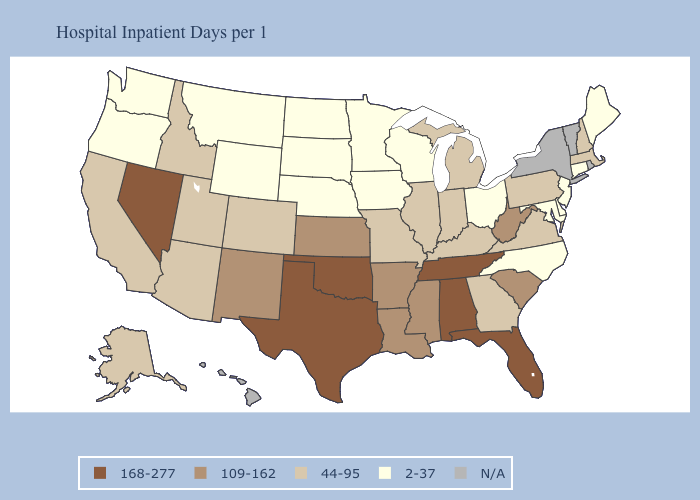Does Utah have the lowest value in the USA?
Write a very short answer. No. Name the states that have a value in the range N/A?
Give a very brief answer. Hawaii, New York, Rhode Island, Vermont. Name the states that have a value in the range 44-95?
Write a very short answer. Alaska, Arizona, California, Colorado, Georgia, Idaho, Illinois, Indiana, Kentucky, Massachusetts, Michigan, Missouri, New Hampshire, Pennsylvania, Utah, Virginia. Name the states that have a value in the range 2-37?
Give a very brief answer. Connecticut, Delaware, Iowa, Maine, Maryland, Minnesota, Montana, Nebraska, New Jersey, North Carolina, North Dakota, Ohio, Oregon, South Dakota, Washington, Wisconsin, Wyoming. Which states have the lowest value in the USA?
Concise answer only. Connecticut, Delaware, Iowa, Maine, Maryland, Minnesota, Montana, Nebraska, New Jersey, North Carolina, North Dakota, Ohio, Oregon, South Dakota, Washington, Wisconsin, Wyoming. Which states have the lowest value in the USA?
Quick response, please. Connecticut, Delaware, Iowa, Maine, Maryland, Minnesota, Montana, Nebraska, New Jersey, North Carolina, North Dakota, Ohio, Oregon, South Dakota, Washington, Wisconsin, Wyoming. What is the value of Oregon?
Be succinct. 2-37. What is the lowest value in the USA?
Write a very short answer. 2-37. Does the first symbol in the legend represent the smallest category?
Give a very brief answer. No. Name the states that have a value in the range 44-95?
Concise answer only. Alaska, Arizona, California, Colorado, Georgia, Idaho, Illinois, Indiana, Kentucky, Massachusetts, Michigan, Missouri, New Hampshire, Pennsylvania, Utah, Virginia. Name the states that have a value in the range 168-277?
Keep it brief. Alabama, Florida, Nevada, Oklahoma, Tennessee, Texas. What is the lowest value in states that border Mississippi?
Be succinct. 109-162. 